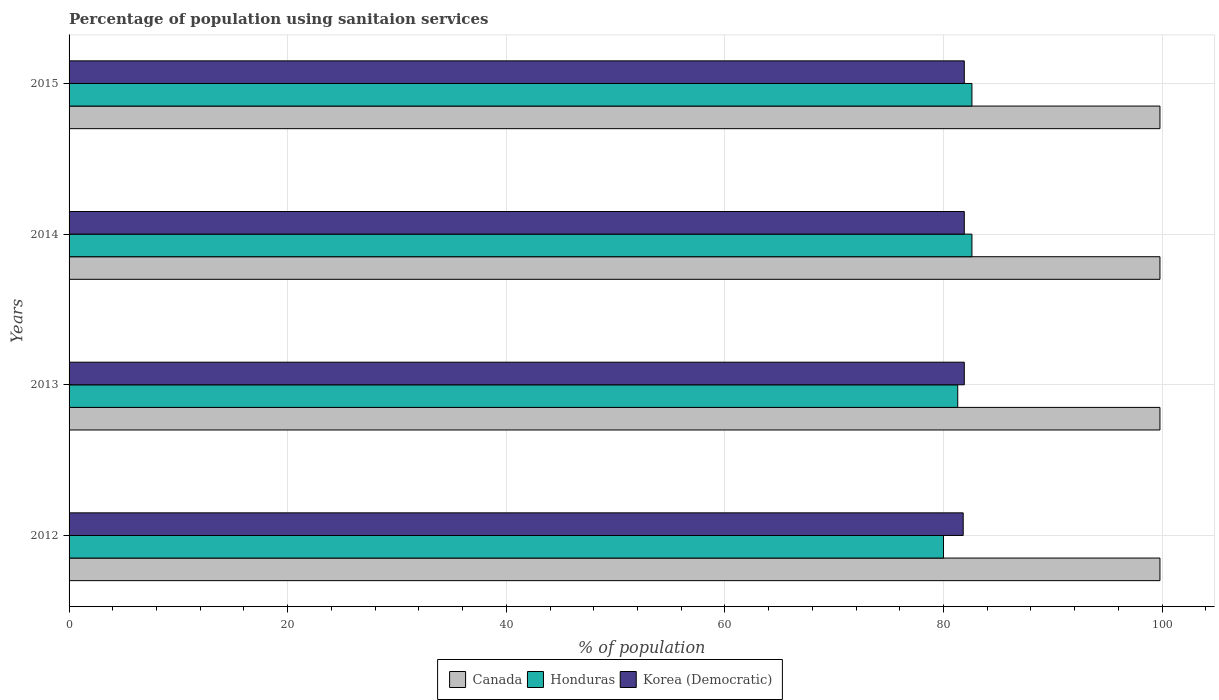How many groups of bars are there?
Ensure brevity in your answer.  4. How many bars are there on the 2nd tick from the top?
Ensure brevity in your answer.  3. How many bars are there on the 4th tick from the bottom?
Your answer should be very brief. 3. What is the label of the 2nd group of bars from the top?
Your answer should be very brief. 2014. In how many cases, is the number of bars for a given year not equal to the number of legend labels?
Provide a succinct answer. 0. What is the percentage of population using sanitaion services in Canada in 2015?
Your response must be concise. 99.8. Across all years, what is the maximum percentage of population using sanitaion services in Honduras?
Offer a very short reply. 82.6. Across all years, what is the minimum percentage of population using sanitaion services in Korea (Democratic)?
Offer a terse response. 81.8. In which year was the percentage of population using sanitaion services in Korea (Democratic) maximum?
Your response must be concise. 2013. In which year was the percentage of population using sanitaion services in Korea (Democratic) minimum?
Provide a short and direct response. 2012. What is the total percentage of population using sanitaion services in Honduras in the graph?
Provide a succinct answer. 326.5. What is the difference between the percentage of population using sanitaion services in Honduras in 2013 and that in 2015?
Provide a succinct answer. -1.3. What is the average percentage of population using sanitaion services in Canada per year?
Provide a succinct answer. 99.8. In the year 2012, what is the difference between the percentage of population using sanitaion services in Canada and percentage of population using sanitaion services in Honduras?
Give a very brief answer. 19.8. In how many years, is the percentage of population using sanitaion services in Honduras greater than 72 %?
Keep it short and to the point. 4. What is the ratio of the percentage of population using sanitaion services in Korea (Democratic) in 2012 to that in 2015?
Your answer should be compact. 1. Is the difference between the percentage of population using sanitaion services in Canada in 2013 and 2015 greater than the difference between the percentage of population using sanitaion services in Honduras in 2013 and 2015?
Your response must be concise. Yes. What is the difference between the highest and the second highest percentage of population using sanitaion services in Honduras?
Ensure brevity in your answer.  0. What is the difference between the highest and the lowest percentage of population using sanitaion services in Honduras?
Provide a succinct answer. 2.6. What does the 3rd bar from the top in 2015 represents?
Your answer should be compact. Canada. What does the 3rd bar from the bottom in 2012 represents?
Ensure brevity in your answer.  Korea (Democratic). Is it the case that in every year, the sum of the percentage of population using sanitaion services in Korea (Democratic) and percentage of population using sanitaion services in Canada is greater than the percentage of population using sanitaion services in Honduras?
Your answer should be compact. Yes. How many bars are there?
Your answer should be very brief. 12. Are all the bars in the graph horizontal?
Give a very brief answer. Yes. How many years are there in the graph?
Offer a very short reply. 4. How are the legend labels stacked?
Your answer should be compact. Horizontal. What is the title of the graph?
Provide a short and direct response. Percentage of population using sanitaion services. What is the label or title of the X-axis?
Provide a succinct answer. % of population. What is the label or title of the Y-axis?
Ensure brevity in your answer.  Years. What is the % of population in Canada in 2012?
Keep it short and to the point. 99.8. What is the % of population of Honduras in 2012?
Your answer should be compact. 80. What is the % of population of Korea (Democratic) in 2012?
Give a very brief answer. 81.8. What is the % of population in Canada in 2013?
Your response must be concise. 99.8. What is the % of population of Honduras in 2013?
Make the answer very short. 81.3. What is the % of population in Korea (Democratic) in 2013?
Your answer should be compact. 81.9. What is the % of population in Canada in 2014?
Offer a very short reply. 99.8. What is the % of population in Honduras in 2014?
Keep it short and to the point. 82.6. What is the % of population in Korea (Democratic) in 2014?
Ensure brevity in your answer.  81.9. What is the % of population in Canada in 2015?
Provide a short and direct response. 99.8. What is the % of population of Honduras in 2015?
Offer a terse response. 82.6. What is the % of population in Korea (Democratic) in 2015?
Keep it short and to the point. 81.9. Across all years, what is the maximum % of population of Canada?
Offer a very short reply. 99.8. Across all years, what is the maximum % of population in Honduras?
Your response must be concise. 82.6. Across all years, what is the maximum % of population of Korea (Democratic)?
Ensure brevity in your answer.  81.9. Across all years, what is the minimum % of population of Canada?
Your answer should be very brief. 99.8. Across all years, what is the minimum % of population in Honduras?
Your answer should be very brief. 80. Across all years, what is the minimum % of population of Korea (Democratic)?
Give a very brief answer. 81.8. What is the total % of population of Canada in the graph?
Give a very brief answer. 399.2. What is the total % of population in Honduras in the graph?
Provide a short and direct response. 326.5. What is the total % of population of Korea (Democratic) in the graph?
Make the answer very short. 327.5. What is the difference between the % of population in Canada in 2012 and that in 2014?
Your response must be concise. 0. What is the difference between the % of population in Canada in 2012 and that in 2015?
Make the answer very short. 0. What is the difference between the % of population in Honduras in 2013 and that in 2014?
Your answer should be very brief. -1.3. What is the difference between the % of population in Korea (Democratic) in 2013 and that in 2014?
Your answer should be very brief. 0. What is the difference between the % of population of Honduras in 2013 and that in 2015?
Your answer should be compact. -1.3. What is the difference between the % of population in Canada in 2014 and that in 2015?
Give a very brief answer. 0. What is the difference between the % of population of Honduras in 2014 and that in 2015?
Your answer should be very brief. 0. What is the difference between the % of population in Korea (Democratic) in 2014 and that in 2015?
Give a very brief answer. 0. What is the difference between the % of population in Canada in 2012 and the % of population in Korea (Democratic) in 2014?
Give a very brief answer. 17.9. What is the difference between the % of population in Canada in 2012 and the % of population in Honduras in 2015?
Give a very brief answer. 17.2. What is the difference between the % of population of Canada in 2012 and the % of population of Korea (Democratic) in 2015?
Your answer should be very brief. 17.9. What is the difference between the % of population of Canada in 2013 and the % of population of Honduras in 2015?
Offer a very short reply. 17.2. What is the difference between the % of population of Honduras in 2013 and the % of population of Korea (Democratic) in 2015?
Offer a terse response. -0.6. What is the difference between the % of population of Canada in 2014 and the % of population of Honduras in 2015?
Give a very brief answer. 17.2. What is the average % of population in Canada per year?
Your answer should be compact. 99.8. What is the average % of population in Honduras per year?
Offer a terse response. 81.62. What is the average % of population of Korea (Democratic) per year?
Provide a short and direct response. 81.88. In the year 2012, what is the difference between the % of population in Canada and % of population in Honduras?
Ensure brevity in your answer.  19.8. In the year 2013, what is the difference between the % of population of Canada and % of population of Korea (Democratic)?
Offer a very short reply. 17.9. In the year 2013, what is the difference between the % of population in Honduras and % of population in Korea (Democratic)?
Give a very brief answer. -0.6. In the year 2014, what is the difference between the % of population of Honduras and % of population of Korea (Democratic)?
Keep it short and to the point. 0.7. In the year 2015, what is the difference between the % of population in Canada and % of population in Honduras?
Your answer should be compact. 17.2. In the year 2015, what is the difference between the % of population in Canada and % of population in Korea (Democratic)?
Keep it short and to the point. 17.9. In the year 2015, what is the difference between the % of population in Honduras and % of population in Korea (Democratic)?
Your answer should be compact. 0.7. What is the ratio of the % of population in Canada in 2012 to that in 2013?
Offer a very short reply. 1. What is the ratio of the % of population of Canada in 2012 to that in 2014?
Your response must be concise. 1. What is the ratio of the % of population in Honduras in 2012 to that in 2014?
Your answer should be very brief. 0.97. What is the ratio of the % of population of Honduras in 2012 to that in 2015?
Offer a very short reply. 0.97. What is the ratio of the % of population of Korea (Democratic) in 2012 to that in 2015?
Offer a very short reply. 1. What is the ratio of the % of population in Canada in 2013 to that in 2014?
Your answer should be very brief. 1. What is the ratio of the % of population of Honduras in 2013 to that in 2014?
Ensure brevity in your answer.  0.98. What is the ratio of the % of population in Korea (Democratic) in 2013 to that in 2014?
Give a very brief answer. 1. What is the ratio of the % of population in Canada in 2013 to that in 2015?
Make the answer very short. 1. What is the ratio of the % of population in Honduras in 2013 to that in 2015?
Make the answer very short. 0.98. What is the ratio of the % of population of Korea (Democratic) in 2013 to that in 2015?
Give a very brief answer. 1. What is the ratio of the % of population in Honduras in 2014 to that in 2015?
Provide a short and direct response. 1. What is the difference between the highest and the lowest % of population in Canada?
Make the answer very short. 0. 